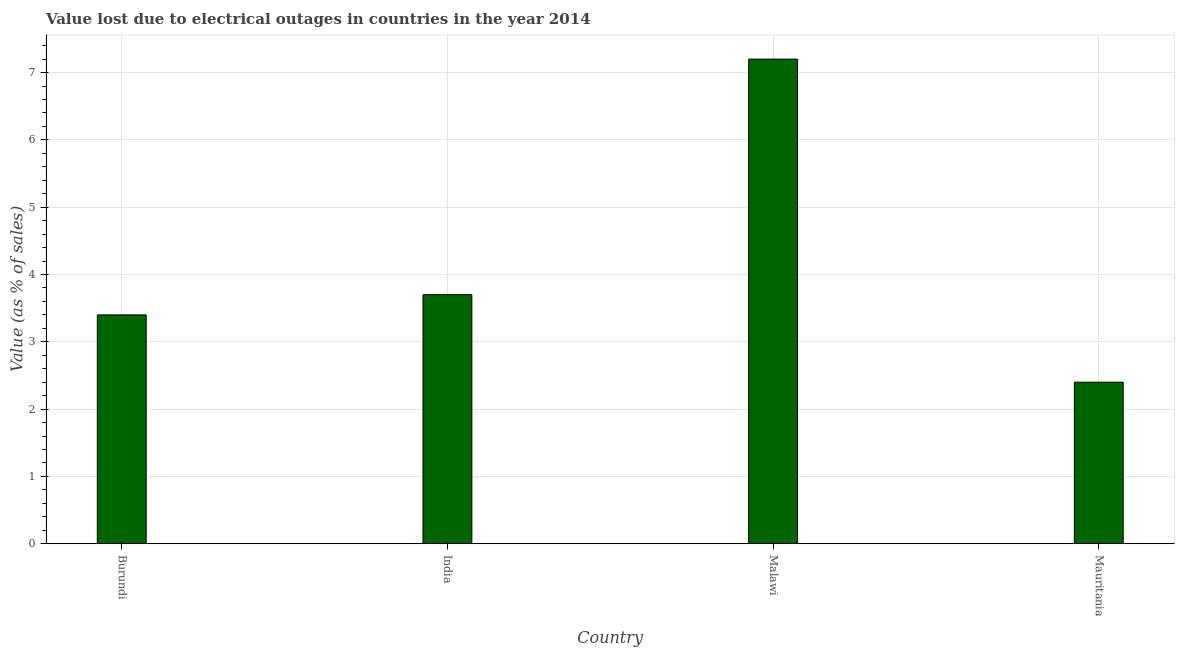What is the title of the graph?
Your answer should be very brief. Value lost due to electrical outages in countries in the year 2014. What is the label or title of the X-axis?
Your answer should be very brief. Country. What is the label or title of the Y-axis?
Your response must be concise. Value (as % of sales). What is the value lost due to electrical outages in Mauritania?
Your answer should be compact. 2.4. Across all countries, what is the minimum value lost due to electrical outages?
Keep it short and to the point. 2.4. In which country was the value lost due to electrical outages maximum?
Your answer should be compact. Malawi. In which country was the value lost due to electrical outages minimum?
Keep it short and to the point. Mauritania. What is the average value lost due to electrical outages per country?
Your response must be concise. 4.17. What is the median value lost due to electrical outages?
Ensure brevity in your answer.  3.55. What is the ratio of the value lost due to electrical outages in Burundi to that in Malawi?
Offer a very short reply. 0.47. What is the difference between the highest and the lowest value lost due to electrical outages?
Keep it short and to the point. 4.8. What is the difference between two consecutive major ticks on the Y-axis?
Your answer should be compact. 1. Are the values on the major ticks of Y-axis written in scientific E-notation?
Give a very brief answer. No. What is the Value (as % of sales) in Malawi?
Keep it short and to the point. 7.2. What is the Value (as % of sales) of Mauritania?
Offer a very short reply. 2.4. What is the difference between the Value (as % of sales) in Burundi and India?
Keep it short and to the point. -0.3. What is the difference between the Value (as % of sales) in Burundi and Mauritania?
Ensure brevity in your answer.  1. What is the difference between the Value (as % of sales) in India and Mauritania?
Offer a terse response. 1.3. What is the ratio of the Value (as % of sales) in Burundi to that in India?
Offer a very short reply. 0.92. What is the ratio of the Value (as % of sales) in Burundi to that in Malawi?
Ensure brevity in your answer.  0.47. What is the ratio of the Value (as % of sales) in Burundi to that in Mauritania?
Ensure brevity in your answer.  1.42. What is the ratio of the Value (as % of sales) in India to that in Malawi?
Your answer should be very brief. 0.51. What is the ratio of the Value (as % of sales) in India to that in Mauritania?
Provide a succinct answer. 1.54. What is the ratio of the Value (as % of sales) in Malawi to that in Mauritania?
Make the answer very short. 3. 